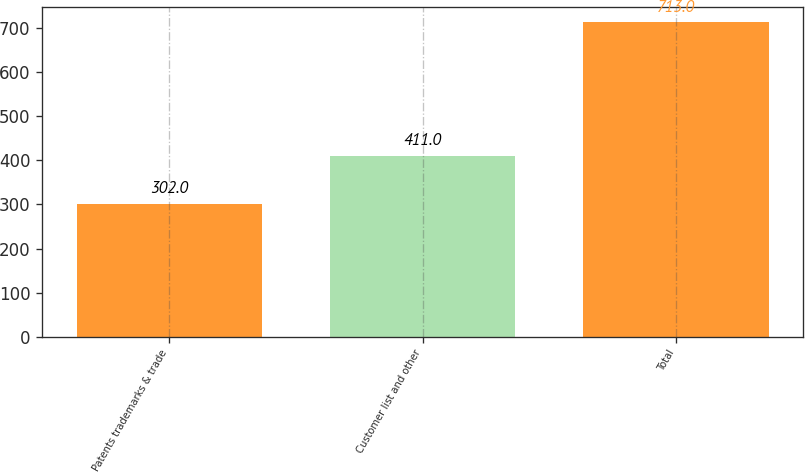<chart> <loc_0><loc_0><loc_500><loc_500><bar_chart><fcel>Patents trademarks & trade<fcel>Customer list and other<fcel>Total<nl><fcel>302<fcel>411<fcel>713<nl></chart> 